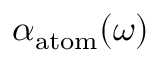Convert formula to latex. <formula><loc_0><loc_0><loc_500><loc_500>\alpha _ { a t o m } ( \omega )</formula> 